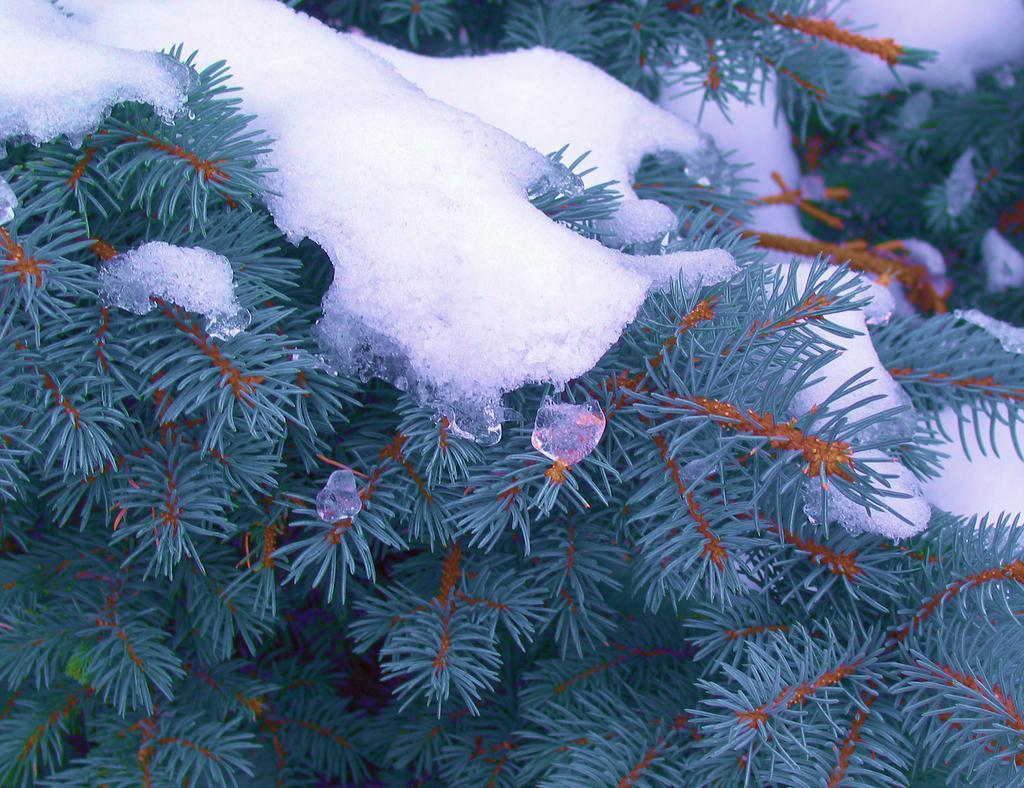How would you summarize this image in a sentence or two? There are plants having green color leaves, on which, there is white color snow. 